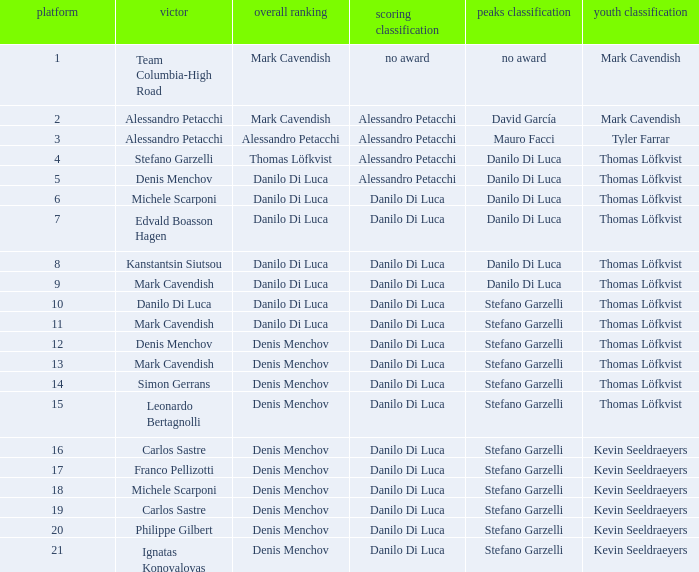When thomas löfkvist possesses the young rider classification and alessandro petacchi secures the points classification, who are the general classifications? Thomas Löfkvist, Danilo Di Luca. 